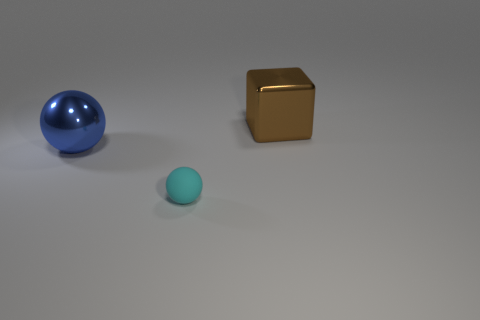Is there a red thing? No, there is no red object present. We can see a blue sphere, a golden cube, and a small cyan sphere all placed against a neutral background. 